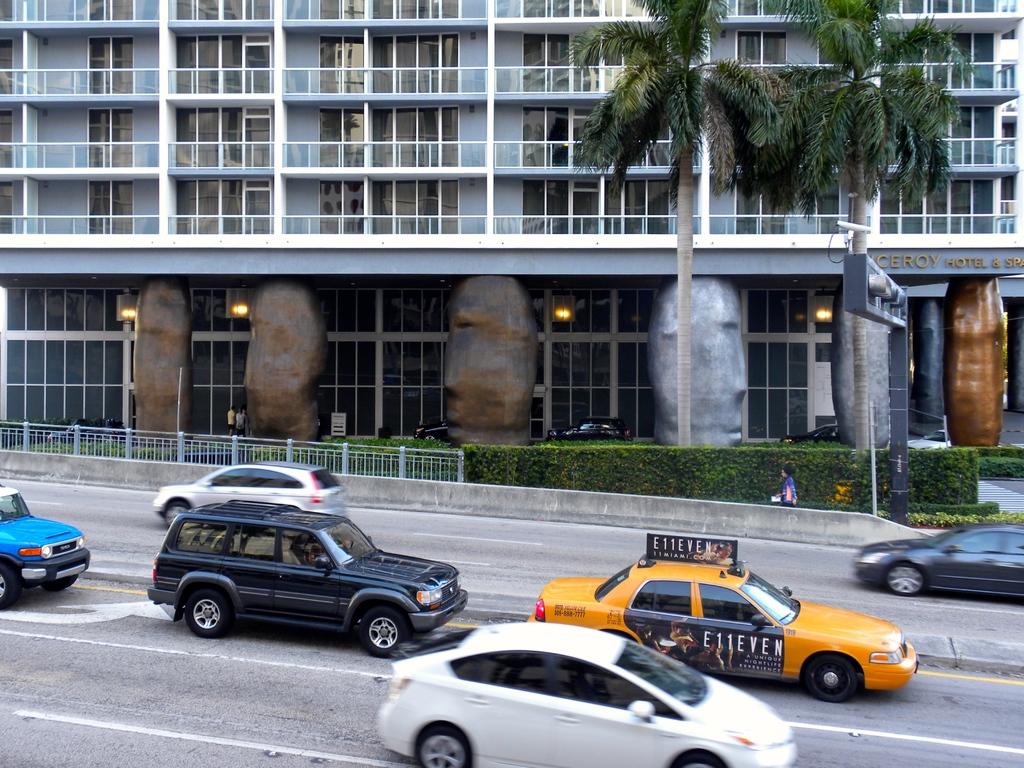What play is being advertised on the taxi?
Your response must be concise. E11even. 